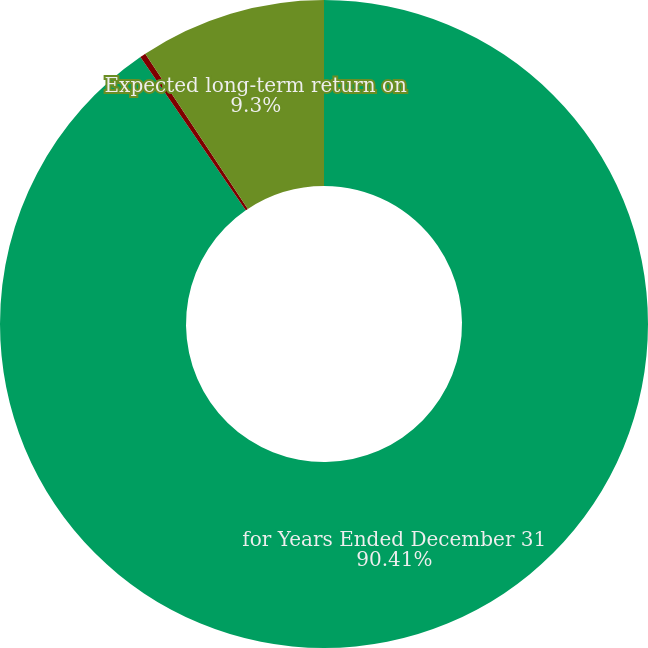Convert chart to OTSL. <chart><loc_0><loc_0><loc_500><loc_500><pie_chart><fcel>for Years Ended December 31<fcel>Weighted-average discount rate<fcel>Expected long-term return on<nl><fcel>90.4%<fcel>0.29%<fcel>9.3%<nl></chart> 